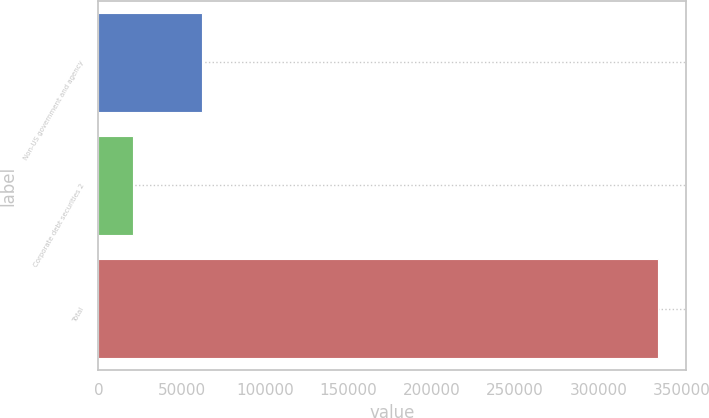Convert chart. <chart><loc_0><loc_0><loc_500><loc_500><bar_chart><fcel>Non-US government and agency<fcel>Corporate debt securities 2<fcel>Total<nl><fcel>62250<fcel>20981<fcel>335835<nl></chart> 